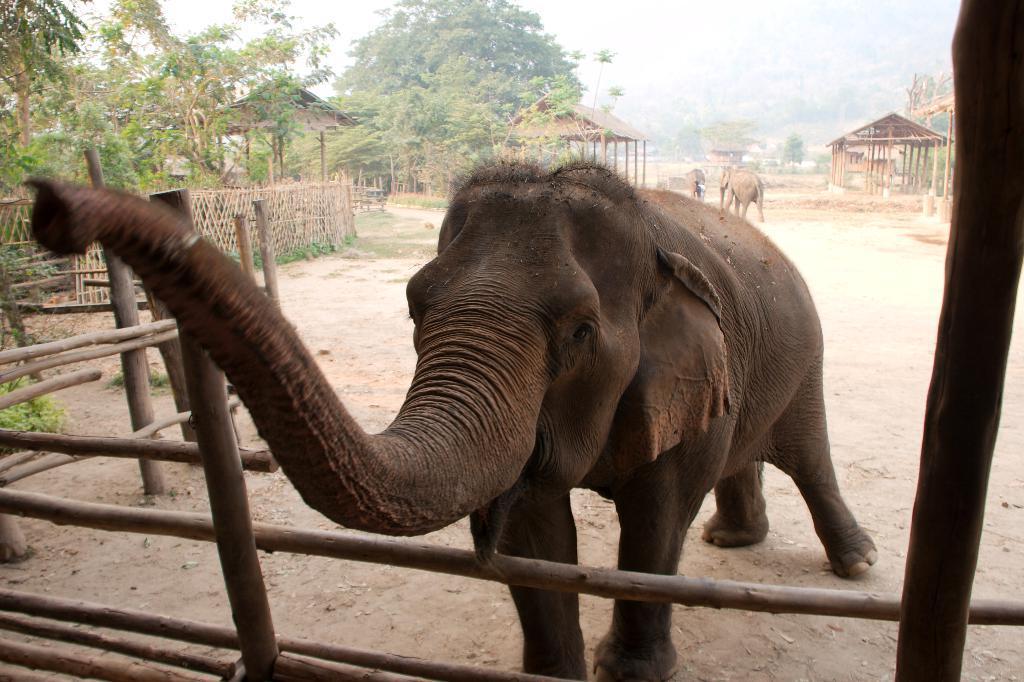In one or two sentences, can you explain what this image depicts? In this image we can see elephant. Background of the image trees, wooden shelters and fencing is there. At the bottom of the image bamboo boundary is there. 